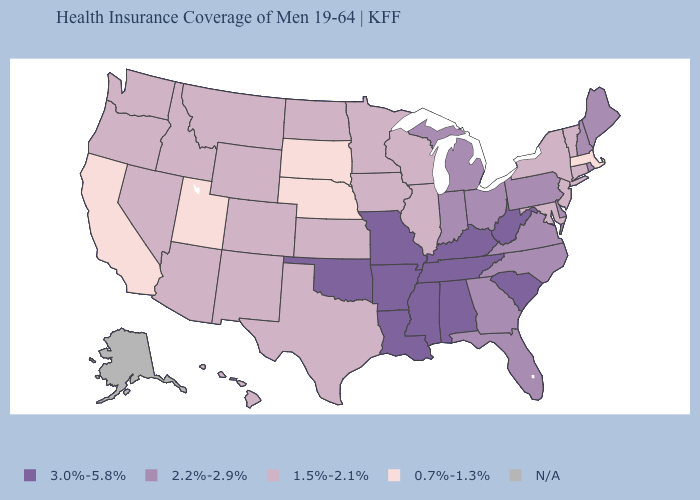Among the states that border Nebraska , does Wyoming have the lowest value?
Keep it brief. No. What is the lowest value in the MidWest?
Short answer required. 0.7%-1.3%. Among the states that border Rhode Island , which have the highest value?
Give a very brief answer. Connecticut. Which states have the lowest value in the West?
Give a very brief answer. California, Utah. Name the states that have a value in the range 3.0%-5.8%?
Short answer required. Alabama, Arkansas, Kentucky, Louisiana, Mississippi, Missouri, Oklahoma, South Carolina, Tennessee, West Virginia. What is the lowest value in the USA?
Concise answer only. 0.7%-1.3%. Name the states that have a value in the range 3.0%-5.8%?
Quick response, please. Alabama, Arkansas, Kentucky, Louisiana, Mississippi, Missouri, Oklahoma, South Carolina, Tennessee, West Virginia. What is the value of Arkansas?
Short answer required. 3.0%-5.8%. Among the states that border South Dakota , does Iowa have the lowest value?
Be succinct. No. Is the legend a continuous bar?
Quick response, please. No. Which states have the highest value in the USA?
Keep it brief. Alabama, Arkansas, Kentucky, Louisiana, Mississippi, Missouri, Oklahoma, South Carolina, Tennessee, West Virginia. Which states hav the highest value in the South?
Short answer required. Alabama, Arkansas, Kentucky, Louisiana, Mississippi, Oklahoma, South Carolina, Tennessee, West Virginia. Among the states that border Oregon , does Nevada have the lowest value?
Keep it brief. No. What is the value of Arizona?
Concise answer only. 1.5%-2.1%. What is the value of Alabama?
Write a very short answer. 3.0%-5.8%. 